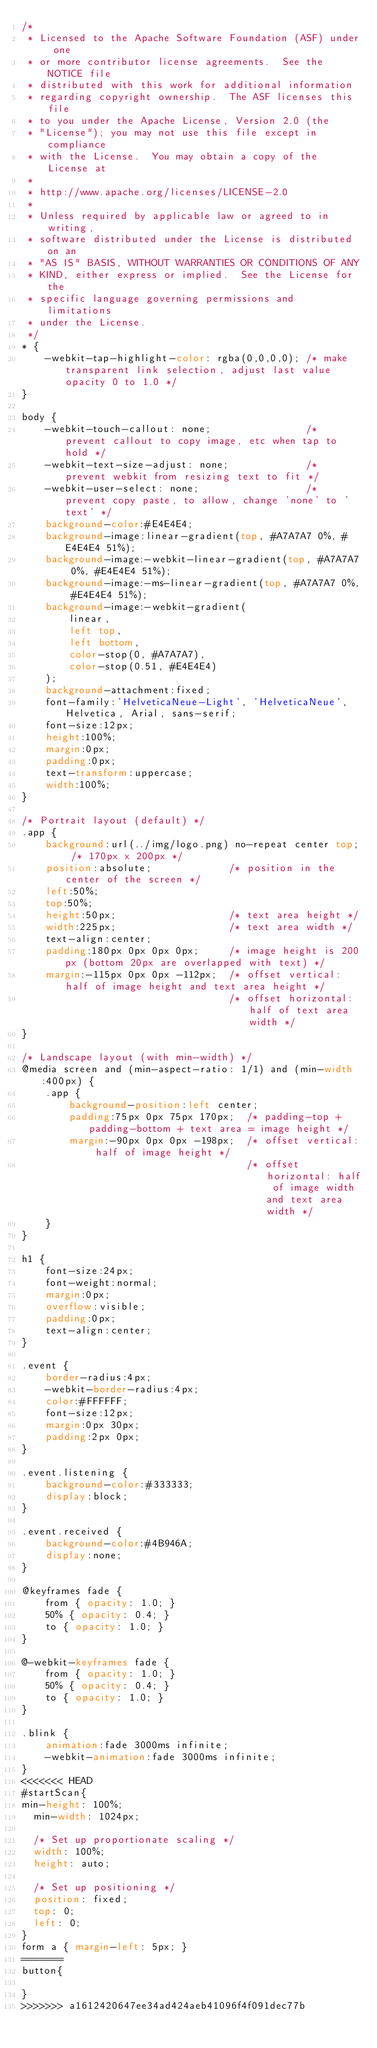<code> <loc_0><loc_0><loc_500><loc_500><_CSS_>/*
 * Licensed to the Apache Software Foundation (ASF) under one
 * or more contributor license agreements.  See the NOTICE file
 * distributed with this work for additional information
 * regarding copyright ownership.  The ASF licenses this file
 * to you under the Apache License, Version 2.0 (the
 * "License"); you may not use this file except in compliance
 * with the License.  You may obtain a copy of the License at
 *
 * http://www.apache.org/licenses/LICENSE-2.0
 *
 * Unless required by applicable law or agreed to in writing,
 * software distributed under the License is distributed on an
 * "AS IS" BASIS, WITHOUT WARRANTIES OR CONDITIONS OF ANY
 * KIND, either express or implied.  See the License for the
 * specific language governing permissions and limitations
 * under the License.
 */
* {
    -webkit-tap-highlight-color: rgba(0,0,0,0); /* make transparent link selection, adjust last value opacity 0 to 1.0 */
}

body {
    -webkit-touch-callout: none;                /* prevent callout to copy image, etc when tap to hold */
    -webkit-text-size-adjust: none;             /* prevent webkit from resizing text to fit */
    -webkit-user-select: none;                  /* prevent copy paste, to allow, change 'none' to 'text' */
    background-color:#E4E4E4;
    background-image:linear-gradient(top, #A7A7A7 0%, #E4E4E4 51%);
    background-image:-webkit-linear-gradient(top, #A7A7A7 0%, #E4E4E4 51%);
    background-image:-ms-linear-gradient(top, #A7A7A7 0%, #E4E4E4 51%);
    background-image:-webkit-gradient(
        linear,
        left top,
        left bottom,
        color-stop(0, #A7A7A7),
        color-stop(0.51, #E4E4E4)
    );
    background-attachment:fixed;
    font-family:'HelveticaNeue-Light', 'HelveticaNeue', Helvetica, Arial, sans-serif;
    font-size:12px;
    height:100%;
    margin:0px;
    padding:0px;
    text-transform:uppercase;
    width:100%;
}

/* Portrait layout (default) */
.app {
    background:url(../img/logo.png) no-repeat center top; /* 170px x 200px */
    position:absolute;             /* position in the center of the screen */
    left:50%;
    top:50%;
    height:50px;                   /* text area height */
    width:225px;                   /* text area width */
    text-align:center;
    padding:180px 0px 0px 0px;     /* image height is 200px (bottom 20px are overlapped with text) */
    margin:-115px 0px 0px -112px;  /* offset vertical: half of image height and text area height */
                                   /* offset horizontal: half of text area width */
}

/* Landscape layout (with min-width) */
@media screen and (min-aspect-ratio: 1/1) and (min-width:400px) {
    .app {
        background-position:left center;
        padding:75px 0px 75px 170px;  /* padding-top + padding-bottom + text area = image height */
        margin:-90px 0px 0px -198px;  /* offset vertical: half of image height */
                                      /* offset horizontal: half of image width and text area width */
    }
}

h1 {
    font-size:24px;
    font-weight:normal;
    margin:0px;
    overflow:visible;
    padding:0px;
    text-align:center;
}

.event {
    border-radius:4px;
    -webkit-border-radius:4px;
    color:#FFFFFF;
    font-size:12px;
    margin:0px 30px;
    padding:2px 0px;
}

.event.listening {
    background-color:#333333;
    display:block;
}

.event.received {
    background-color:#4B946A;
    display:none;
}

@keyframes fade {
    from { opacity: 1.0; }
    50% { opacity: 0.4; }
    to { opacity: 1.0; }
}
 
@-webkit-keyframes fade {
    from { opacity: 1.0; }
    50% { opacity: 0.4; }
    to { opacity: 1.0; }
}
 
.blink {
    animation:fade 3000ms infinite;
    -webkit-animation:fade 3000ms infinite;
}
<<<<<<< HEAD
#startScan{
min-height: 100%;
  min-width: 1024px;

  /* Set up proportionate scaling */
  width: 100%;
  height: auto;

  /* Set up positioning */
  position: fixed;
  top: 0;
  left: 0;
}
form a { margin-left: 5px; }
=======
button{

}
>>>>>>> a1612420647ee34ad424aeb41096f4f091dec77b
</code> 